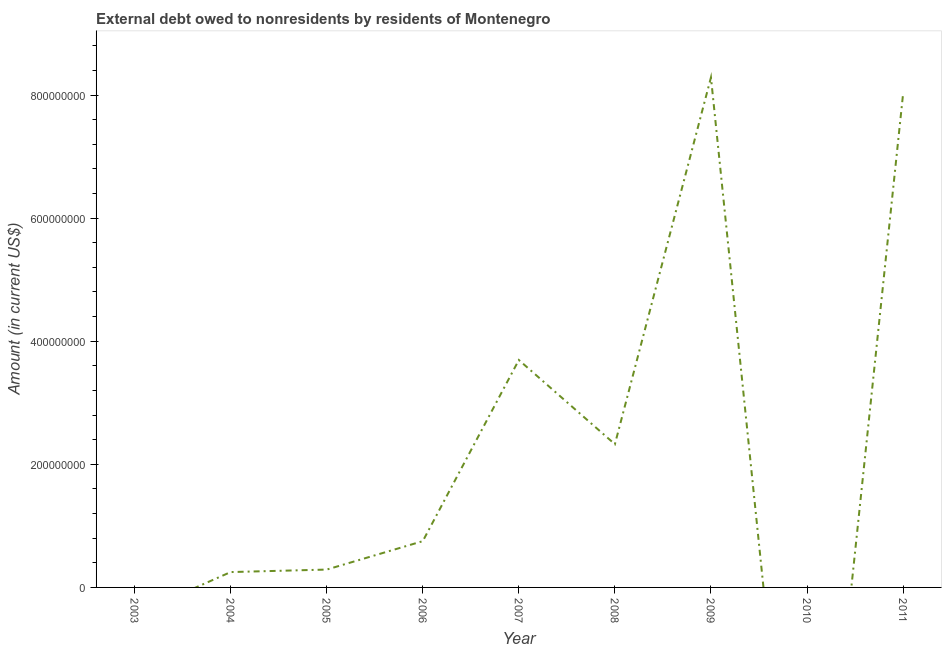What is the debt in 2009?
Provide a succinct answer. 8.29e+08. Across all years, what is the maximum debt?
Your answer should be compact. 8.29e+08. Across all years, what is the minimum debt?
Offer a very short reply. 0. In which year was the debt maximum?
Offer a terse response. 2009. What is the sum of the debt?
Offer a very short reply. 2.36e+09. What is the difference between the debt in 2008 and 2011?
Offer a very short reply. -5.69e+08. What is the average debt per year?
Provide a short and direct response. 2.62e+08. What is the median debt?
Offer a very short reply. 7.52e+07. What is the ratio of the debt in 2004 to that in 2006?
Your answer should be very brief. 0.33. Is the difference between the debt in 2005 and 2007 greater than the difference between any two years?
Keep it short and to the point. No. What is the difference between the highest and the second highest debt?
Your answer should be compact. 2.67e+07. Is the sum of the debt in 2006 and 2007 greater than the maximum debt across all years?
Make the answer very short. No. What is the difference between the highest and the lowest debt?
Keep it short and to the point. 8.29e+08. Does the debt monotonically increase over the years?
Give a very brief answer. No. How many years are there in the graph?
Your answer should be very brief. 9. What is the difference between two consecutive major ticks on the Y-axis?
Your answer should be very brief. 2.00e+08. Does the graph contain any zero values?
Ensure brevity in your answer.  Yes. What is the title of the graph?
Your response must be concise. External debt owed to nonresidents by residents of Montenegro. What is the label or title of the X-axis?
Your response must be concise. Year. What is the Amount (in current US$) in 2004?
Your answer should be very brief. 2.50e+07. What is the Amount (in current US$) in 2005?
Keep it short and to the point. 2.90e+07. What is the Amount (in current US$) in 2006?
Give a very brief answer. 7.52e+07. What is the Amount (in current US$) in 2007?
Give a very brief answer. 3.69e+08. What is the Amount (in current US$) in 2008?
Offer a very short reply. 2.33e+08. What is the Amount (in current US$) in 2009?
Your answer should be very brief. 8.29e+08. What is the Amount (in current US$) in 2010?
Provide a short and direct response. 0. What is the Amount (in current US$) of 2011?
Ensure brevity in your answer.  8.02e+08. What is the difference between the Amount (in current US$) in 2004 and 2005?
Make the answer very short. -4.05e+06. What is the difference between the Amount (in current US$) in 2004 and 2006?
Your response must be concise. -5.02e+07. What is the difference between the Amount (in current US$) in 2004 and 2007?
Provide a short and direct response. -3.45e+08. What is the difference between the Amount (in current US$) in 2004 and 2008?
Offer a terse response. -2.08e+08. What is the difference between the Amount (in current US$) in 2004 and 2009?
Provide a succinct answer. -8.04e+08. What is the difference between the Amount (in current US$) in 2004 and 2011?
Your answer should be very brief. -7.77e+08. What is the difference between the Amount (in current US$) in 2005 and 2006?
Give a very brief answer. -4.62e+07. What is the difference between the Amount (in current US$) in 2005 and 2007?
Provide a succinct answer. -3.40e+08. What is the difference between the Amount (in current US$) in 2005 and 2008?
Provide a succinct answer. -2.04e+08. What is the difference between the Amount (in current US$) in 2005 and 2009?
Your response must be concise. -8.00e+08. What is the difference between the Amount (in current US$) in 2005 and 2011?
Offer a very short reply. -7.73e+08. What is the difference between the Amount (in current US$) in 2006 and 2007?
Ensure brevity in your answer.  -2.94e+08. What is the difference between the Amount (in current US$) in 2006 and 2008?
Your answer should be very brief. -1.58e+08. What is the difference between the Amount (in current US$) in 2006 and 2009?
Your answer should be compact. -7.53e+08. What is the difference between the Amount (in current US$) in 2006 and 2011?
Offer a very short reply. -7.27e+08. What is the difference between the Amount (in current US$) in 2007 and 2008?
Make the answer very short. 1.37e+08. What is the difference between the Amount (in current US$) in 2007 and 2009?
Provide a short and direct response. -4.59e+08. What is the difference between the Amount (in current US$) in 2007 and 2011?
Your answer should be compact. -4.32e+08. What is the difference between the Amount (in current US$) in 2008 and 2009?
Provide a succinct answer. -5.96e+08. What is the difference between the Amount (in current US$) in 2008 and 2011?
Offer a very short reply. -5.69e+08. What is the difference between the Amount (in current US$) in 2009 and 2011?
Make the answer very short. 2.67e+07. What is the ratio of the Amount (in current US$) in 2004 to that in 2005?
Offer a terse response. 0.86. What is the ratio of the Amount (in current US$) in 2004 to that in 2006?
Your response must be concise. 0.33. What is the ratio of the Amount (in current US$) in 2004 to that in 2007?
Make the answer very short. 0.07. What is the ratio of the Amount (in current US$) in 2004 to that in 2008?
Ensure brevity in your answer.  0.11. What is the ratio of the Amount (in current US$) in 2004 to that in 2011?
Your answer should be compact. 0.03. What is the ratio of the Amount (in current US$) in 2005 to that in 2006?
Offer a very short reply. 0.39. What is the ratio of the Amount (in current US$) in 2005 to that in 2007?
Ensure brevity in your answer.  0.08. What is the ratio of the Amount (in current US$) in 2005 to that in 2008?
Your response must be concise. 0.12. What is the ratio of the Amount (in current US$) in 2005 to that in 2009?
Offer a terse response. 0.04. What is the ratio of the Amount (in current US$) in 2005 to that in 2011?
Make the answer very short. 0.04. What is the ratio of the Amount (in current US$) in 2006 to that in 2007?
Your response must be concise. 0.2. What is the ratio of the Amount (in current US$) in 2006 to that in 2008?
Offer a terse response. 0.32. What is the ratio of the Amount (in current US$) in 2006 to that in 2009?
Offer a terse response. 0.09. What is the ratio of the Amount (in current US$) in 2006 to that in 2011?
Keep it short and to the point. 0.09. What is the ratio of the Amount (in current US$) in 2007 to that in 2008?
Provide a succinct answer. 1.59. What is the ratio of the Amount (in current US$) in 2007 to that in 2009?
Provide a short and direct response. 0.45. What is the ratio of the Amount (in current US$) in 2007 to that in 2011?
Your answer should be compact. 0.46. What is the ratio of the Amount (in current US$) in 2008 to that in 2009?
Give a very brief answer. 0.28. What is the ratio of the Amount (in current US$) in 2008 to that in 2011?
Give a very brief answer. 0.29. What is the ratio of the Amount (in current US$) in 2009 to that in 2011?
Offer a terse response. 1.03. 